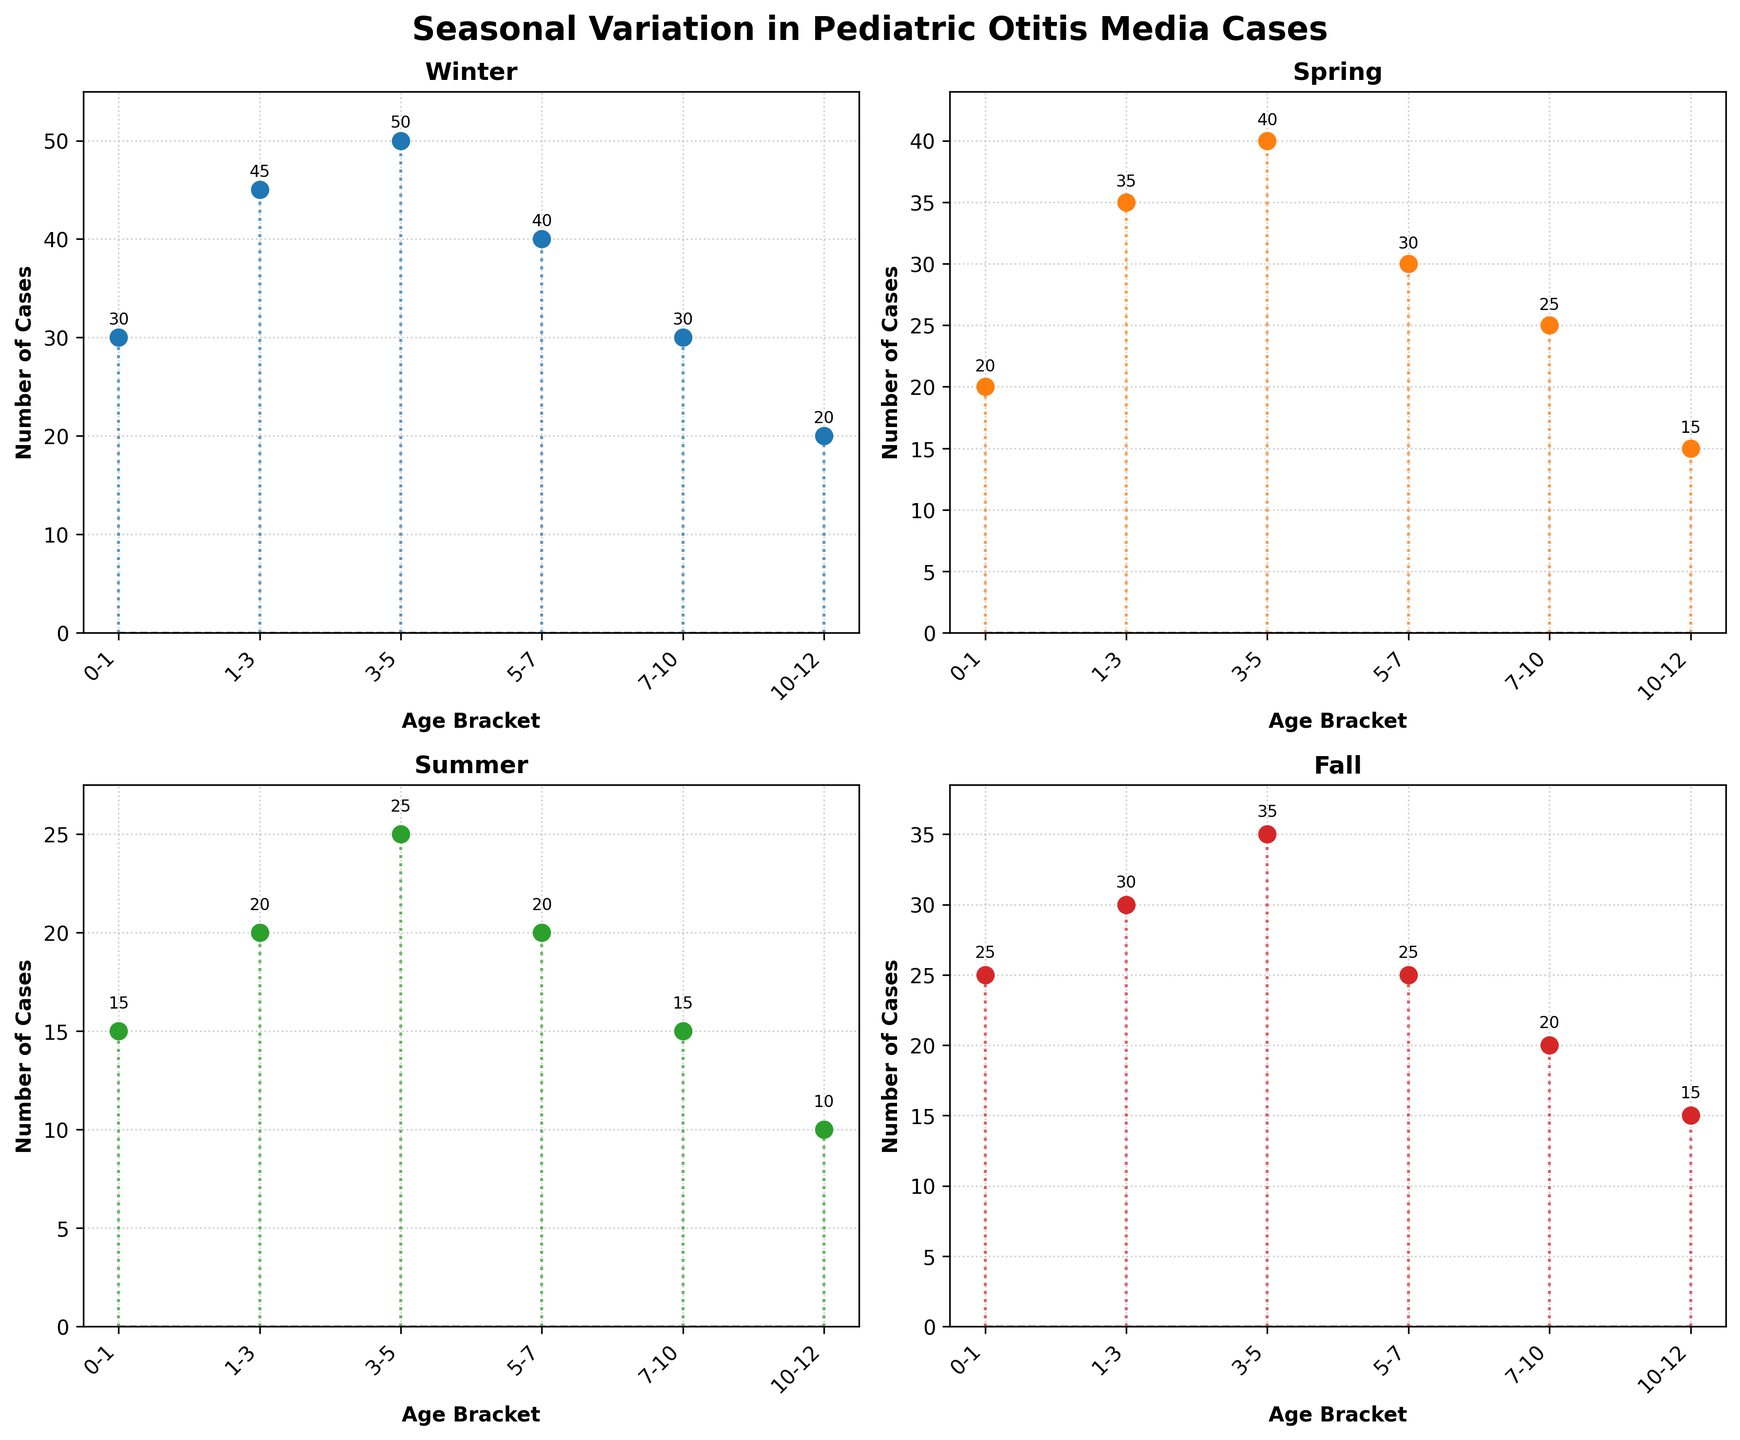What is the title of the figure? The title is usually located at the top of the plot and is meant to provide a summary of what the plot is about. Looking at the rendered figure, we see the title at the top.
Answer: Seasonal Variation in Pediatric Otitis Media Cases Which age bracket has the highest number of otitis media cases in Winter? To determine this, look at the Winter subplot and identify the stem that reaches the highest point along the y-axis. The x-axis label for this stem indicates the age bracket.
Answer: 3-5 How do the number of otitis media cases in Summer compare between the 0-1 and 5-7 age brackets? Examine the Summer subplot and compare the heights of the stems corresponding to the 0-1 and 5-7 age brackets.
Answer: 0-1 has more cases than 5-7 Which season shows the least number of otitis media cases for the 7-10 age bracket? Look at the stems in the 7-10 age bracket across all the subplots for each season. Identify the season where the stem is the shortest.
Answer: Summer What is the general trend in the number of otitis media cases as the age brackets increase from 0-1 to 10-12 in Winter? Examine the stem heights in the Winter subplot and observe how they change as you move from left to right along the x-axis.
Answer: Decreasing How many total otitis media cases were reported for the 3-5 age bracket in all seasons combined? Add the values of the stems for the 3-5 age bracket in each season (Winter, Spring, Summer, Fall). 50 (Winter) + 40 (Spring) + 25 (Summer) + 35 (Fall) = 150
Answer: 150 In which season is the difference between the maximum and minimum number of otitis media cases the largest? Calculate the difference between the maximum and minimum values in each subplot. Compare these differences to determine which is the largest. Winter: 50 - 20 = 30, Spring: 40 - 15 = 25, Summer: 25 - 10 = 15, Fall: 35 - 15 = 20.
Answer: Winter How does the number of cases in the 1-3 age bracket in Fall compare to those in the same bracket in Spring? Locate the 1-3 age bracket in both the Fall and Spring subplots and compare the heights of the stems.
Answer: Fall has fewer cases than Spring Which season has the most balanced distribution of otitis media cases across all age brackets? Review the stem lengths in each subplot to evaluate how similarly distributed the cases are across all age brackets. Look for the subplot with fewer variations in stem lengths.
Answer: Summer 